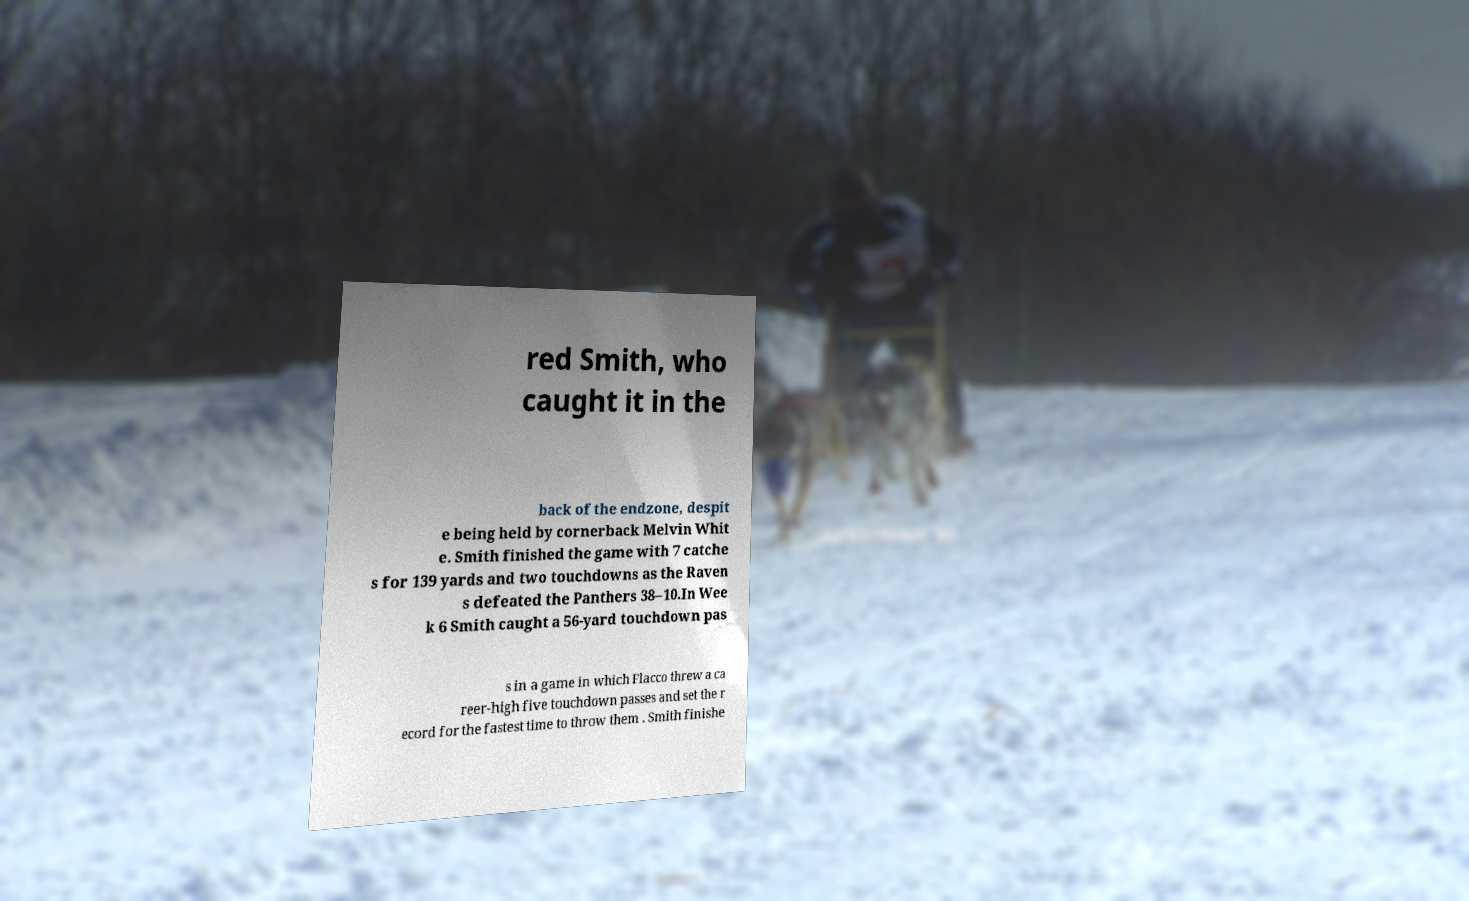Could you extract and type out the text from this image? red Smith, who caught it in the back of the endzone, despit e being held by cornerback Melvin Whit e. Smith finished the game with 7 catche s for 139 yards and two touchdowns as the Raven s defeated the Panthers 38–10.In Wee k 6 Smith caught a 56-yard touchdown pas s in a game in which Flacco threw a ca reer-high five touchdown passes and set the r ecord for the fastest time to throw them . Smith finishe 